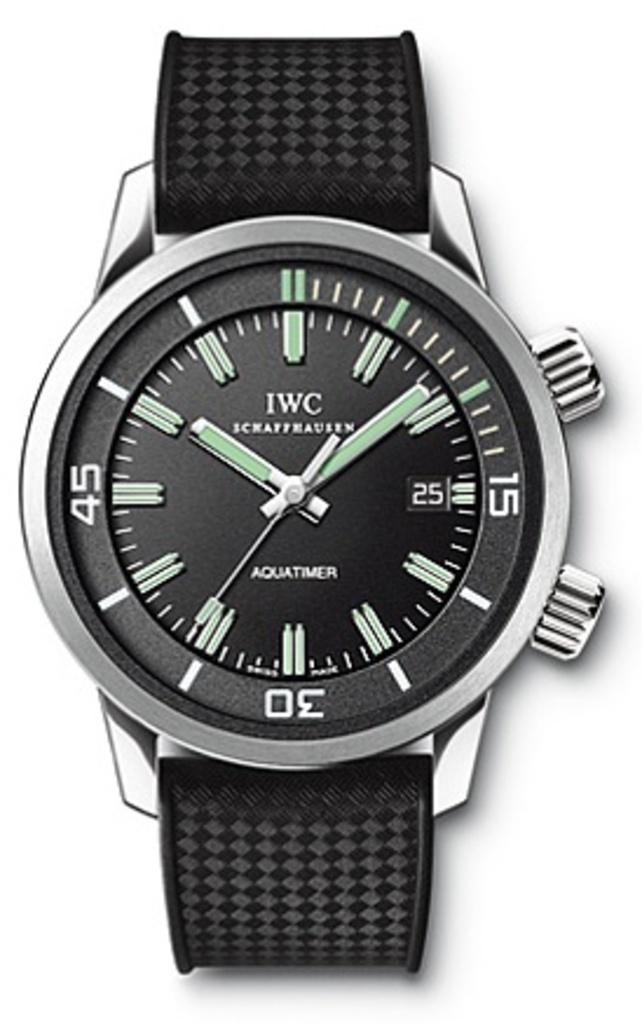<image>
Offer a succinct explanation of the picture presented. A fancy looking black and metal watch with the letters IWC written on the face above a name, Schaffeausen and another word written on the bottom "Aquatimer" 